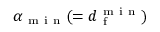Convert formula to latex. <formula><loc_0><loc_0><loc_500><loc_500>\alpha _ { m i n } ( = d _ { f } ^ { m i n } )</formula> 